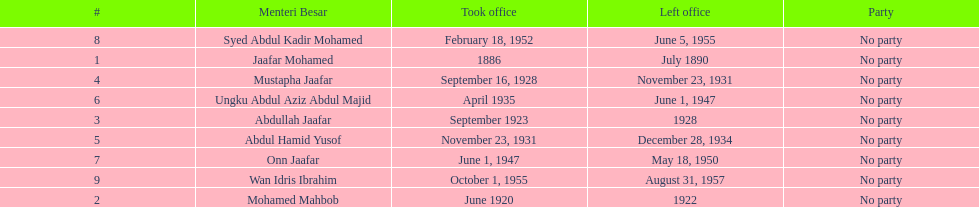Who was in office previous to abdullah jaafar? Mohamed Mahbob. 